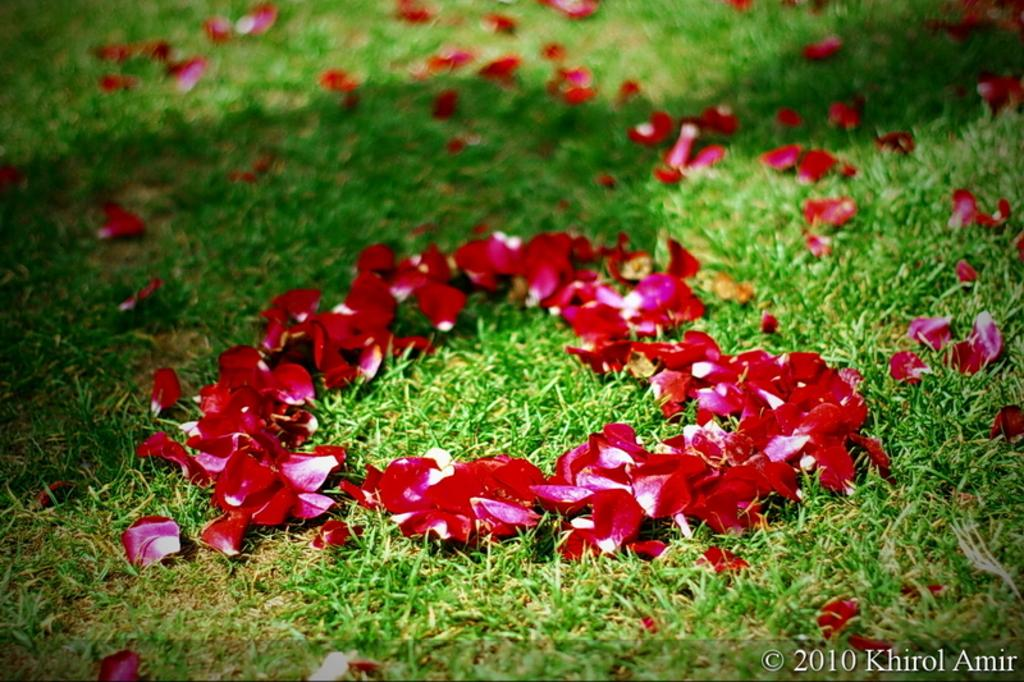What type of flowers can be seen on the grass in the image? There are rose petals on the grass in the image. Where is the text located in the image? The text is at the bottom right of the image. What sound does the spark make in the image? There is no spark present in the image, so it is not possible to determine the sound it might make. 